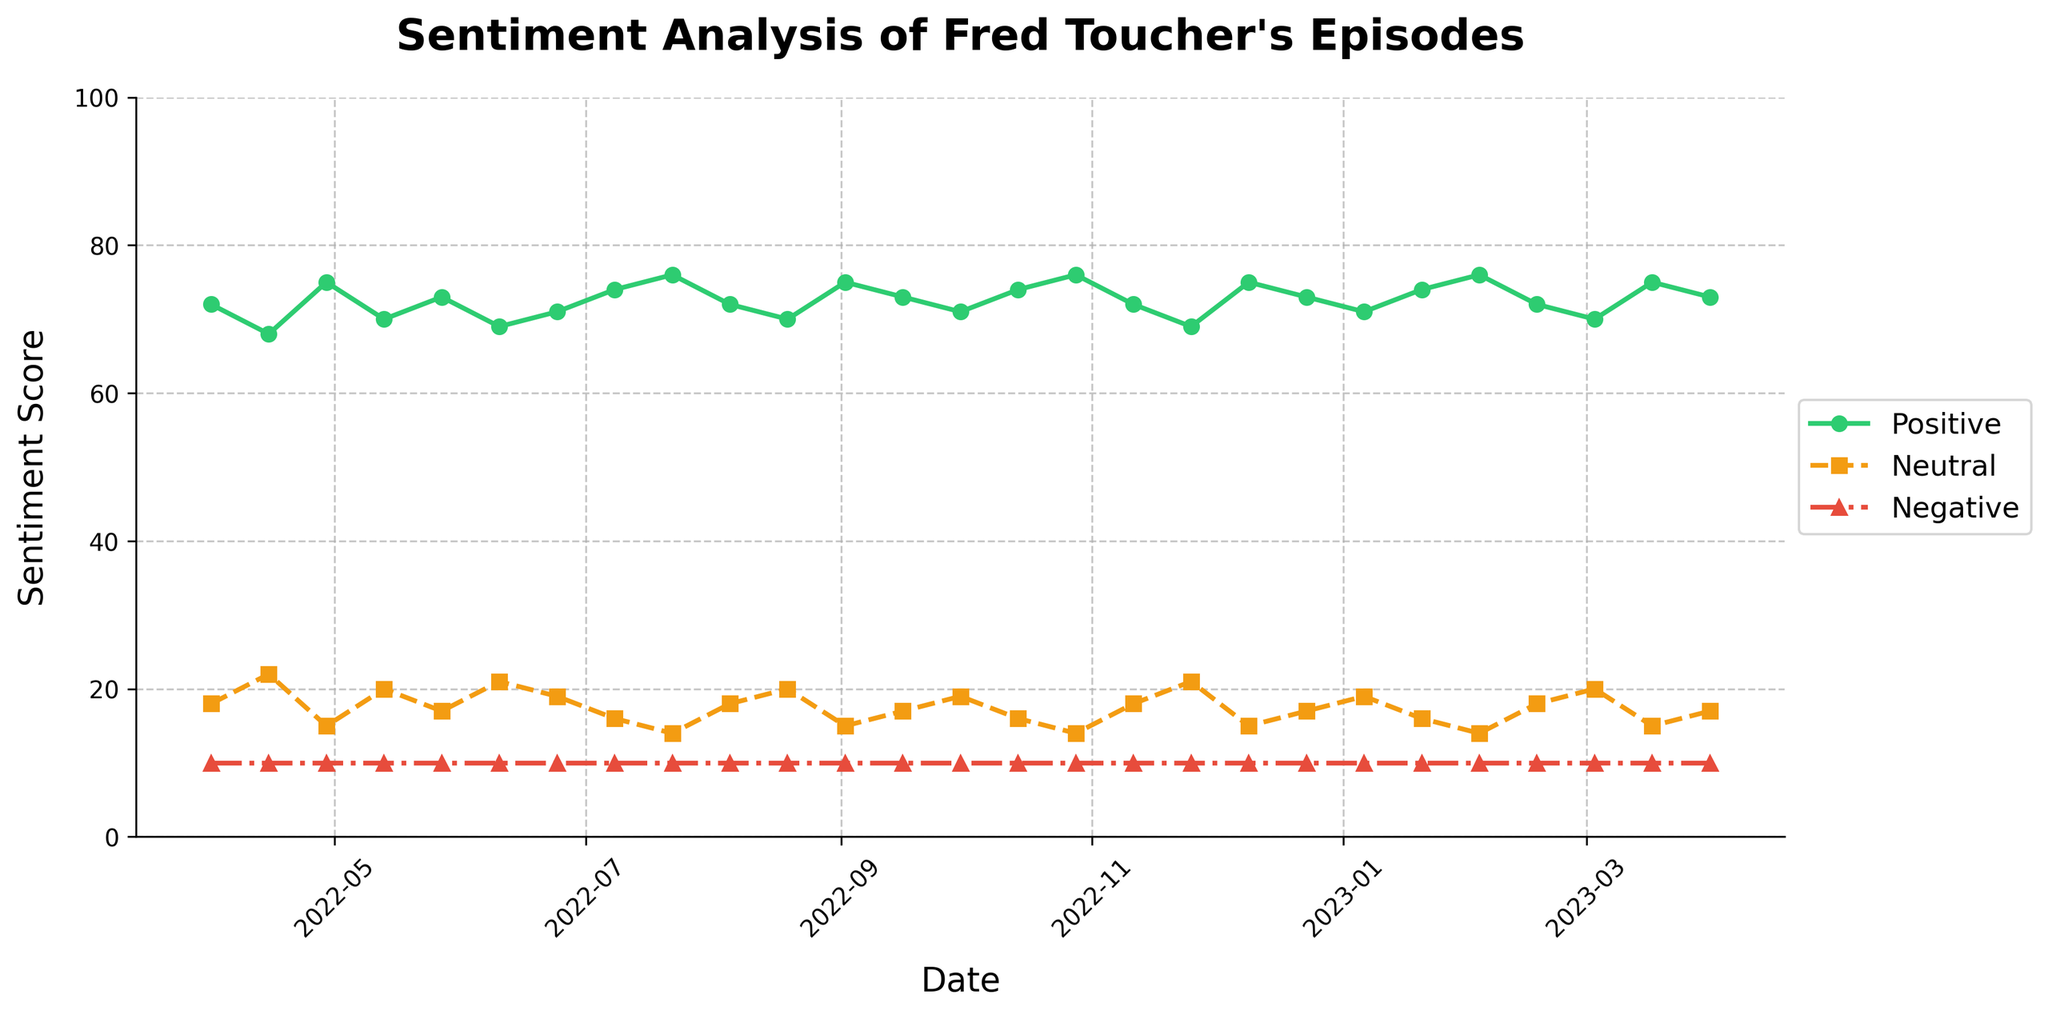What's the overall trend of positive sentiment over the past year? By examining the green line representing positive sentiment, we can observe that it fluctuates but generally trends upward toward the later months, indicating a rise in positive sentiment over the year.
Answer: Upward Which date shows the highest positive sentiment score, and what is the value? The green line peaks at multiple points, notably on dates 2022-07-22, 2022-10-28, and 2023-02-03. The highest value reads as 76.
Answer: 2022-07-22, 2022-10-28, 2023-02-03; 76 How does the lowest neutral sentiment score compare to the highest negative sentiment score? The lowest neutral sentiment score is 14, visible on dates like 2022-07-22 and 2022-10-28. The highest negative sentiment score is 10, visible consistently throughout. Therefore, 14 (neutral) is higher than 10 (negative).
Answer: Neutral > Negative On which date did both positive and neutral sentiments have their highest divergence? By looking at the maximum gap between the green and orange lines, it occurs on the dates 2022-10-28 and 2023-02-03, where the positive sentiment is 76 and the neutral sentiment is 14, making the divergence 62.
Answer: 2022-10-28, 2023-02-03 What's the average positive sentiment score for the months of April and May 2022? Adding the positive sentiment scores for April 2022 (72, 68) and May 2022 (75, 70): (72 + 68 + 75 + 70) / 4 = 71.25
Answer: 71.25 Is there a month where all three sentiment scores are very close to each other? Throughout the line chart, the negative sentiment score constantly stays at 10. The closest proximity occurs relatively when positive sentiment is lower, but neutral and positive remain distinctly apart, so no such month stands out as all three values are similar.
Answer: None During which period did positive sentiment have a noticeable dip? Observing the green line, a noticeable dip occurs between April and June of 2023, as it drops from 73 (end of March) to 70 by the first week of May, and slightly recovers but descends again in June.
Answer: Apr-Jun 2023 What is the median positive sentiment score in the entire year? To find the median, list out all positive sentiment values: {68, 69, 69, 70, 70, 71, 71, 72, 72, 72, 73, 73, 73, 74, 74, 74, 75, 75, 75, 75, 76, 76, 76}. The median value lying in the middle of 23 values is 73.
Answer: 73 What's the difference between the highest and lowest positive sentiment scores over the year? The highest positive sentiment score is 76, and the lowest is 68. The difference is 76 - 68 = 8.
Answer: 8 On which dates did the positive sentiment remain steady despite fluctuations in other sentiments? Positive sentiment stayed flat at around 72 across dates such as from 2022-04-01 to 2022-04-15, and multiple others. Fluctuations are fewer compared to changes in neutral sentiment.
Answer: Several dates (e.g., 2022-04-01 to 2022-04-15) 